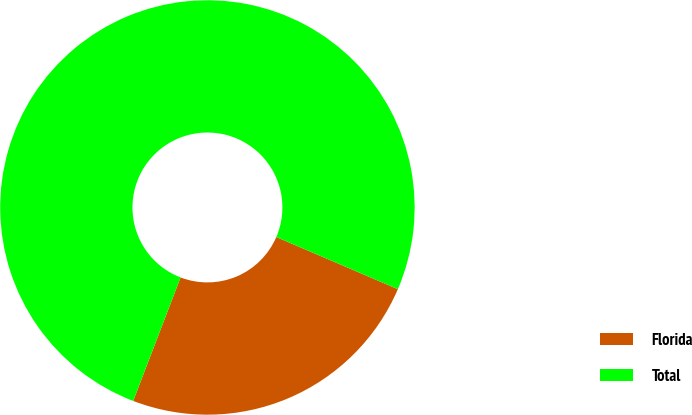Convert chart to OTSL. <chart><loc_0><loc_0><loc_500><loc_500><pie_chart><fcel>Florida<fcel>Total<nl><fcel>24.38%<fcel>75.62%<nl></chart> 